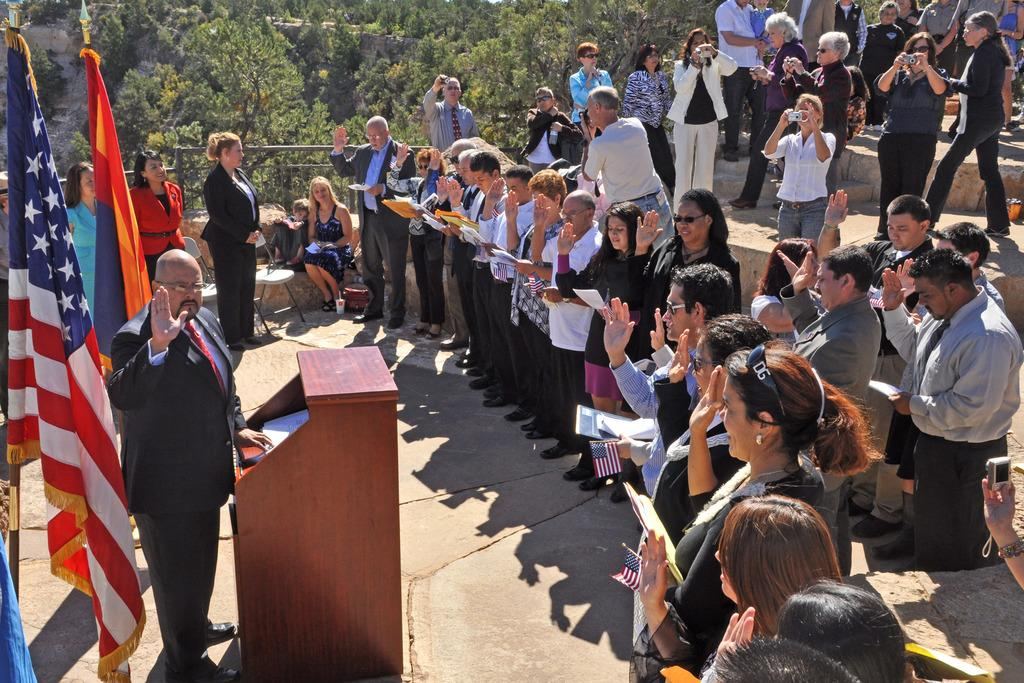What is happening in the image involving the group of people? There is a group of people standing in the image, which suggests they might be attending an event or gathering. What can be seen in the image that represents a symbol or country? There are flags in the image, which often represent countries or organizations. What is the purpose of the podium in the image? The podium in the image is likely used for speeches or presentations, as it is a common feature in such settings. What might the papers in the image be used for? The papers in the image could be used for notes, speeches, or other materials related to the event or gathering. What are the cameras in the image used for? The cameras in the image are likely used for capturing the event or gathering, either by professional photographers or attendees. What type of seating is available in the image? There are chairs in the image, which are commonly used for seating at events or gatherings. How many people are sitting in the image? There are two people sitting in the image. What can be seen in the background of the image? There are trees in the background of the image, which suggests the event or gathering is taking place outdoors or in a location with natural surroundings. What color is the bird that is flying over the downtown area in the image? There is no bird or downtown area present in the image; it features a group of people, flags, a podium, papers, cameras, chairs, and trees in the background. 